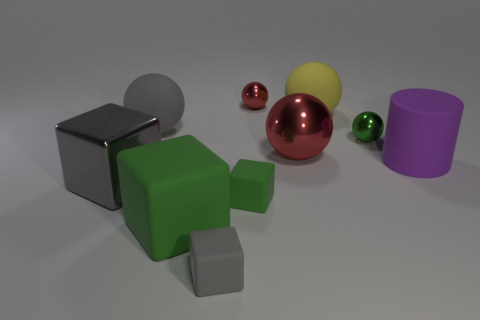What number of objects are small cyan rubber cylinders or small balls?
Your answer should be compact. 2. Is the size of the yellow thing the same as the green cube that is on the right side of the tiny gray object?
Your response must be concise. No. How many other objects are there of the same material as the large red object?
Provide a short and direct response. 3. What number of things are either large metallic cubes left of the tiny green shiny object or big matte objects on the right side of the green shiny ball?
Keep it short and to the point. 2. There is a gray object that is the same shape as the tiny green shiny thing; what material is it?
Make the answer very short. Rubber. Are there any large green matte objects?
Your response must be concise. Yes. There is a metallic object that is in front of the green ball and behind the big matte cylinder; what size is it?
Ensure brevity in your answer.  Large. What is the shape of the large red object?
Keep it short and to the point. Sphere. Are there any big cubes in front of the purple matte cylinder right of the metal block?
Give a very brief answer. Yes. There is a yellow object that is the same size as the gray sphere; what is its material?
Ensure brevity in your answer.  Rubber. 